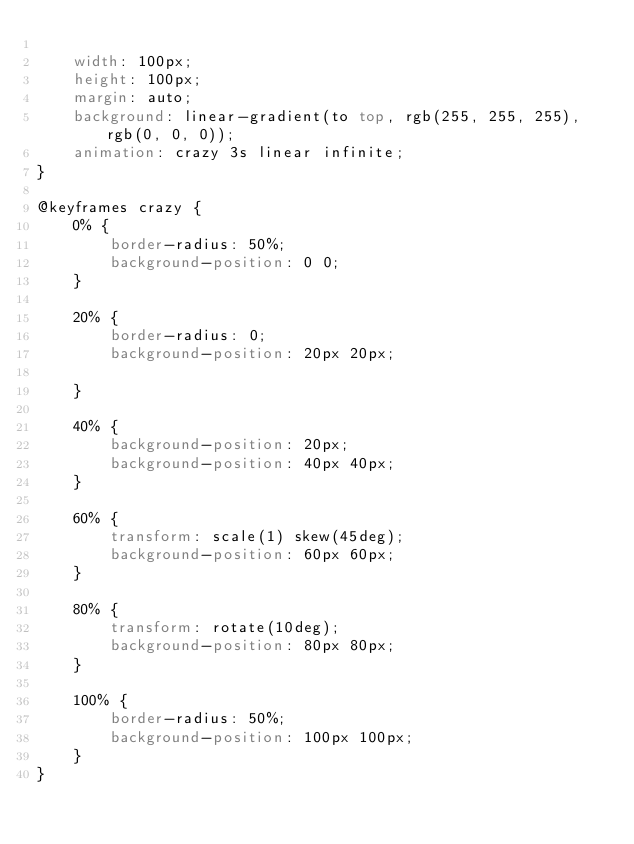Convert code to text. <code><loc_0><loc_0><loc_500><loc_500><_CSS_>
    width: 100px;
    height: 100px;
    margin: auto;
    background: linear-gradient(to top, rgb(255, 255, 255), rgb(0, 0, 0));
    animation: crazy 3s linear infinite;
}

@keyframes crazy {
    0% {
        border-radius: 50%;
        background-position: 0 0;
    }

    20% {
        border-radius: 0;
        background-position: 20px 20px;

    }

    40% {
        background-position: 20px;
        background-position: 40px 40px;
    }

    60% {
        transform: scale(1) skew(45deg);
        background-position: 60px 60px;
    }

    80% {
        transform: rotate(10deg);
        background-position: 80px 80px;
    }

    100% {
        border-radius: 50%;
        background-position: 100px 100px;
    }
}</code> 